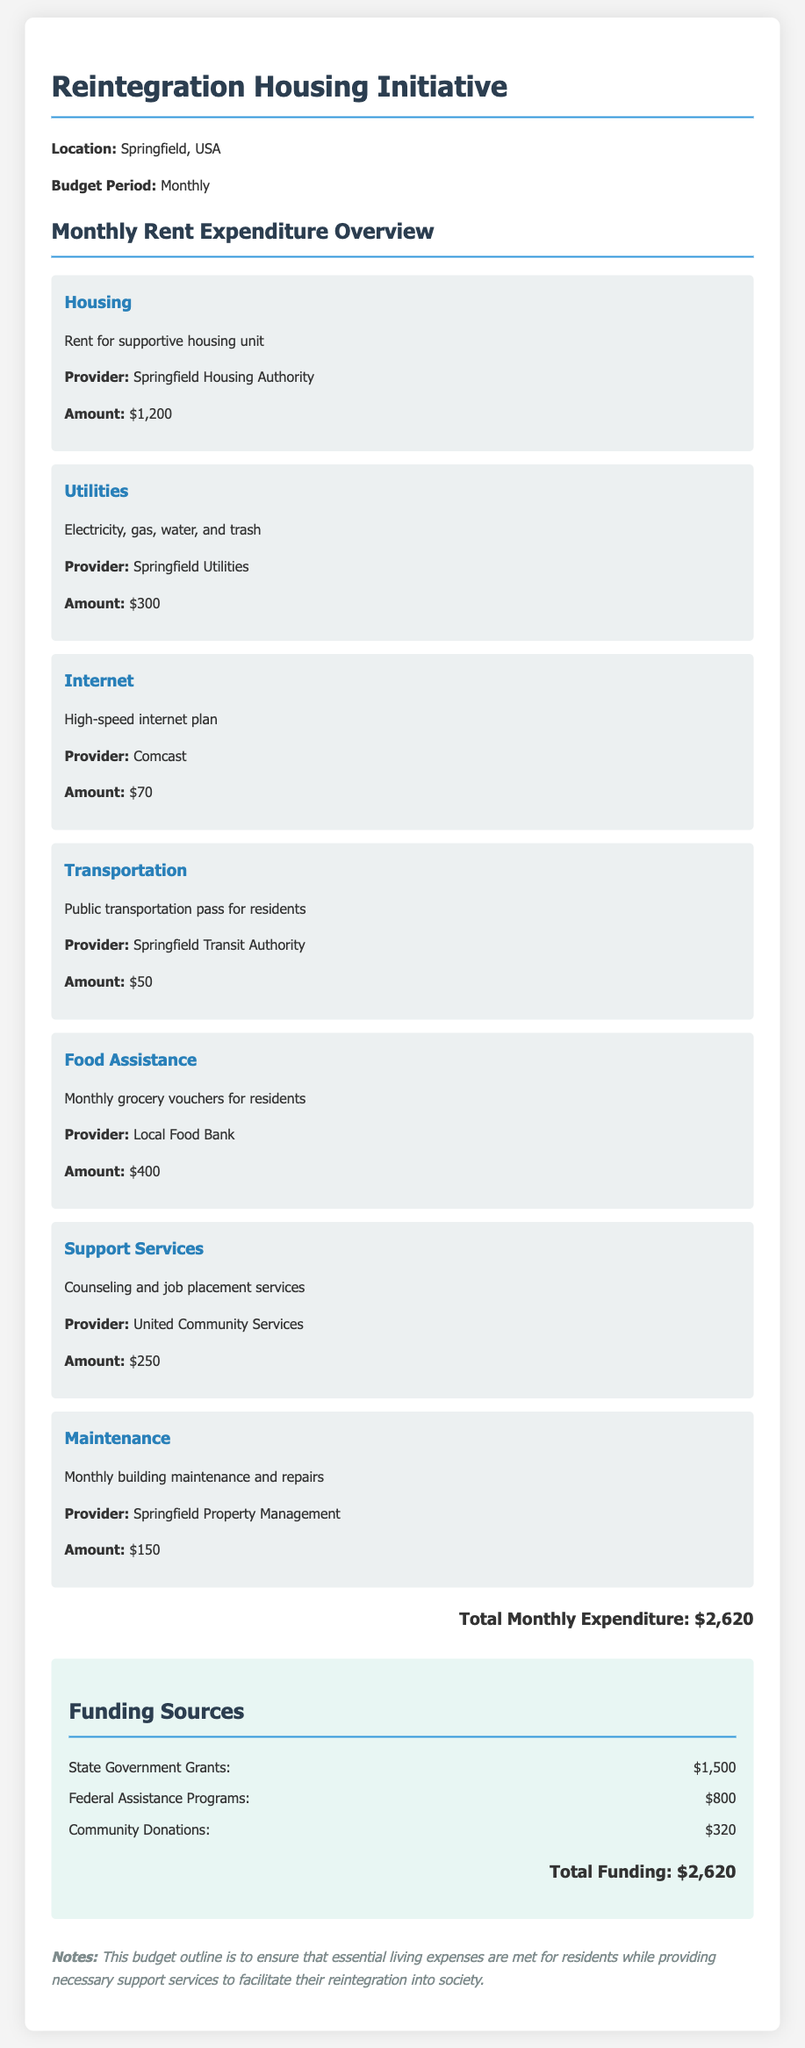What is the total monthly expenditure? The total monthly expenditure is the sum of all itemized costs listed in the document, which equals $2,620.
Answer: $2,620 Who is the provider for housing? The provider for housing as mentioned in the document is the Springfield Housing Authority.
Answer: Springfield Housing Authority How much is allocated for utilities? The amount allocated for utilities, which covers electricity, gas, water, and trash, is specified in the document.
Answer: $300 What type of support services are included? The types of support services included in the budget are counseling and job placement services provided by United Community Services.
Answer: Counseling and job placement services How much funding comes from state government grants? The funding from state government grants is specified in the document, indicating the contribution from state sources.
Answer: $1,500 What is the amount allocated for food assistance? The document lists the amount provided for food assistance in the form of monthly grocery vouchers for residents.
Answer: $400 What is the monthly cost for internet? The monthly cost for high-speed internet as listed in the budget is given clearly in the document.
Answer: $70 What are the total funding sources? The total funding sources are the sum of all specified funding sources, which matches the total expenditure in the document.
Answer: $2,620 What is included in maintenance costs? The maintenance costs cover monthly building maintenance and repairs, as outlined in the document.
Answer: Monthly building maintenance and repairs 